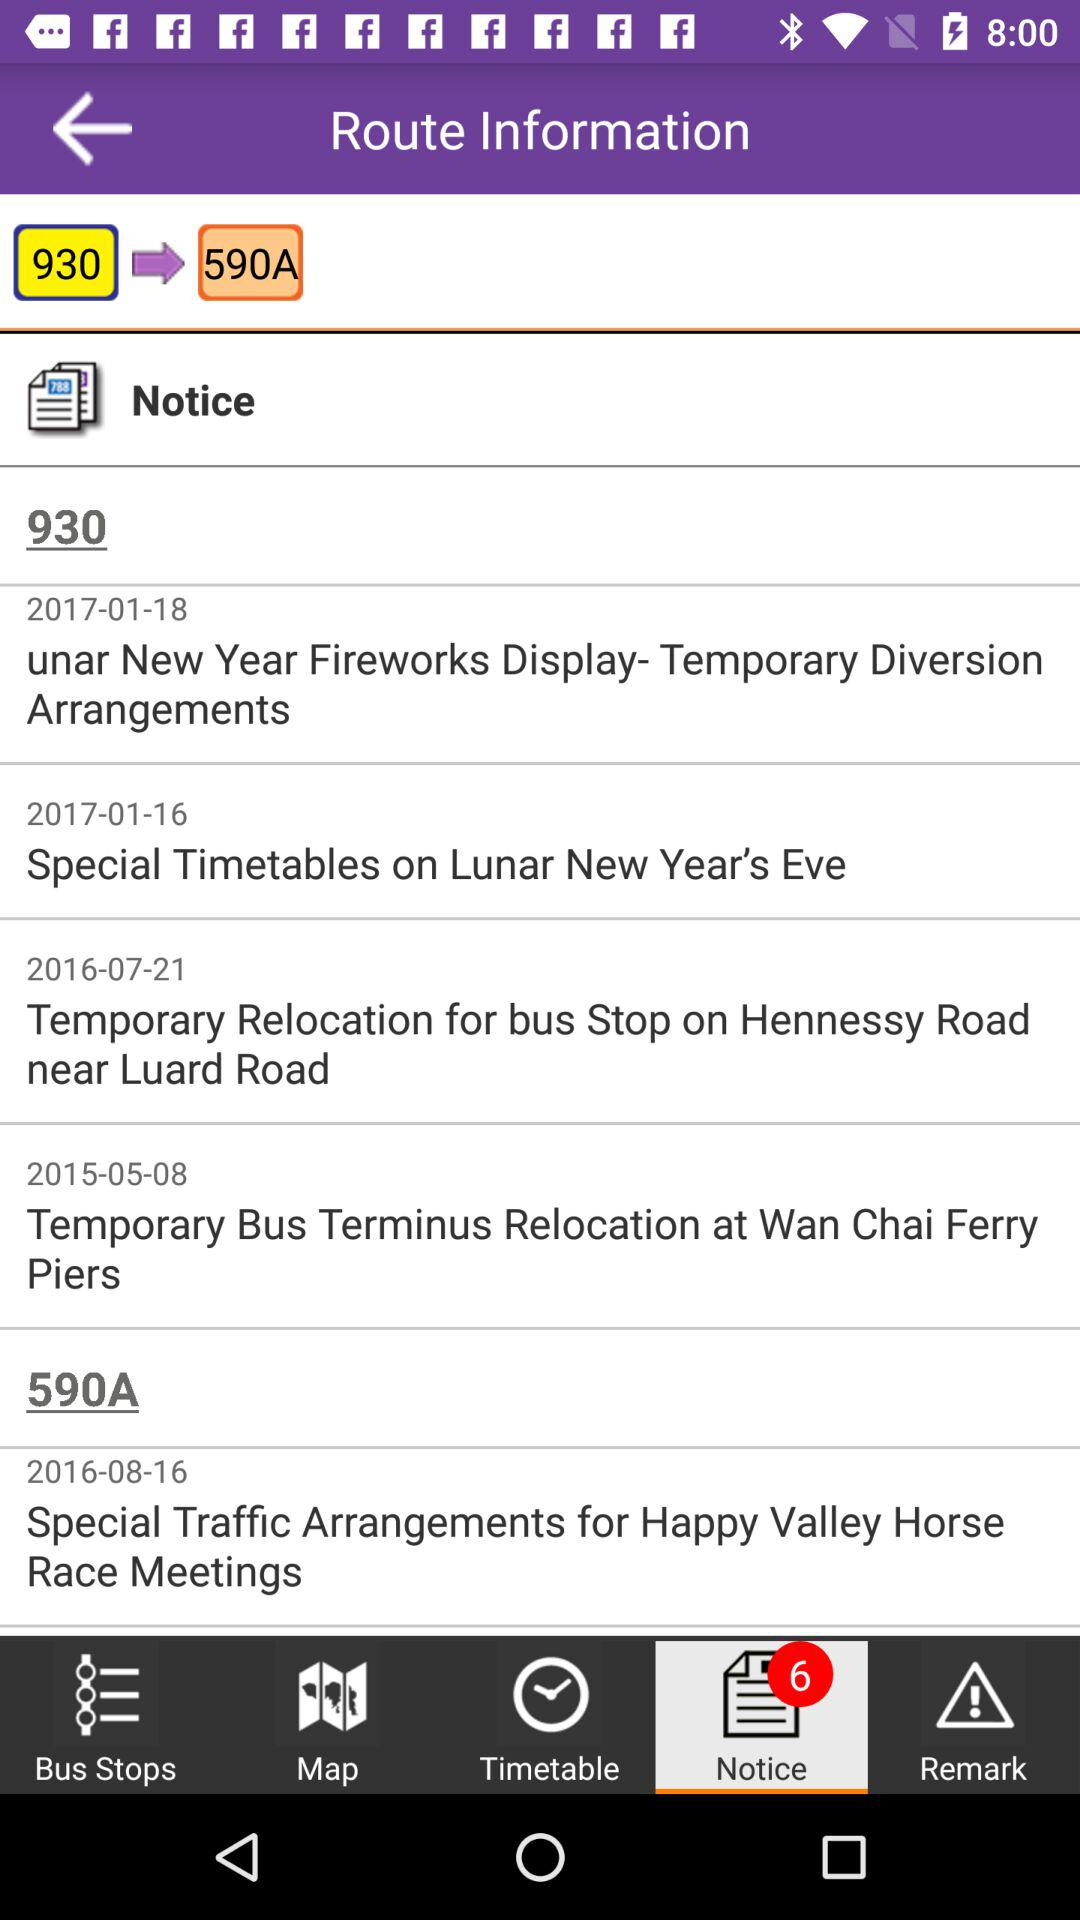What was the route number for the 2016-08-16? What was the route number for 2016-08-16? The route number for August 16, 2016 was 590A. 